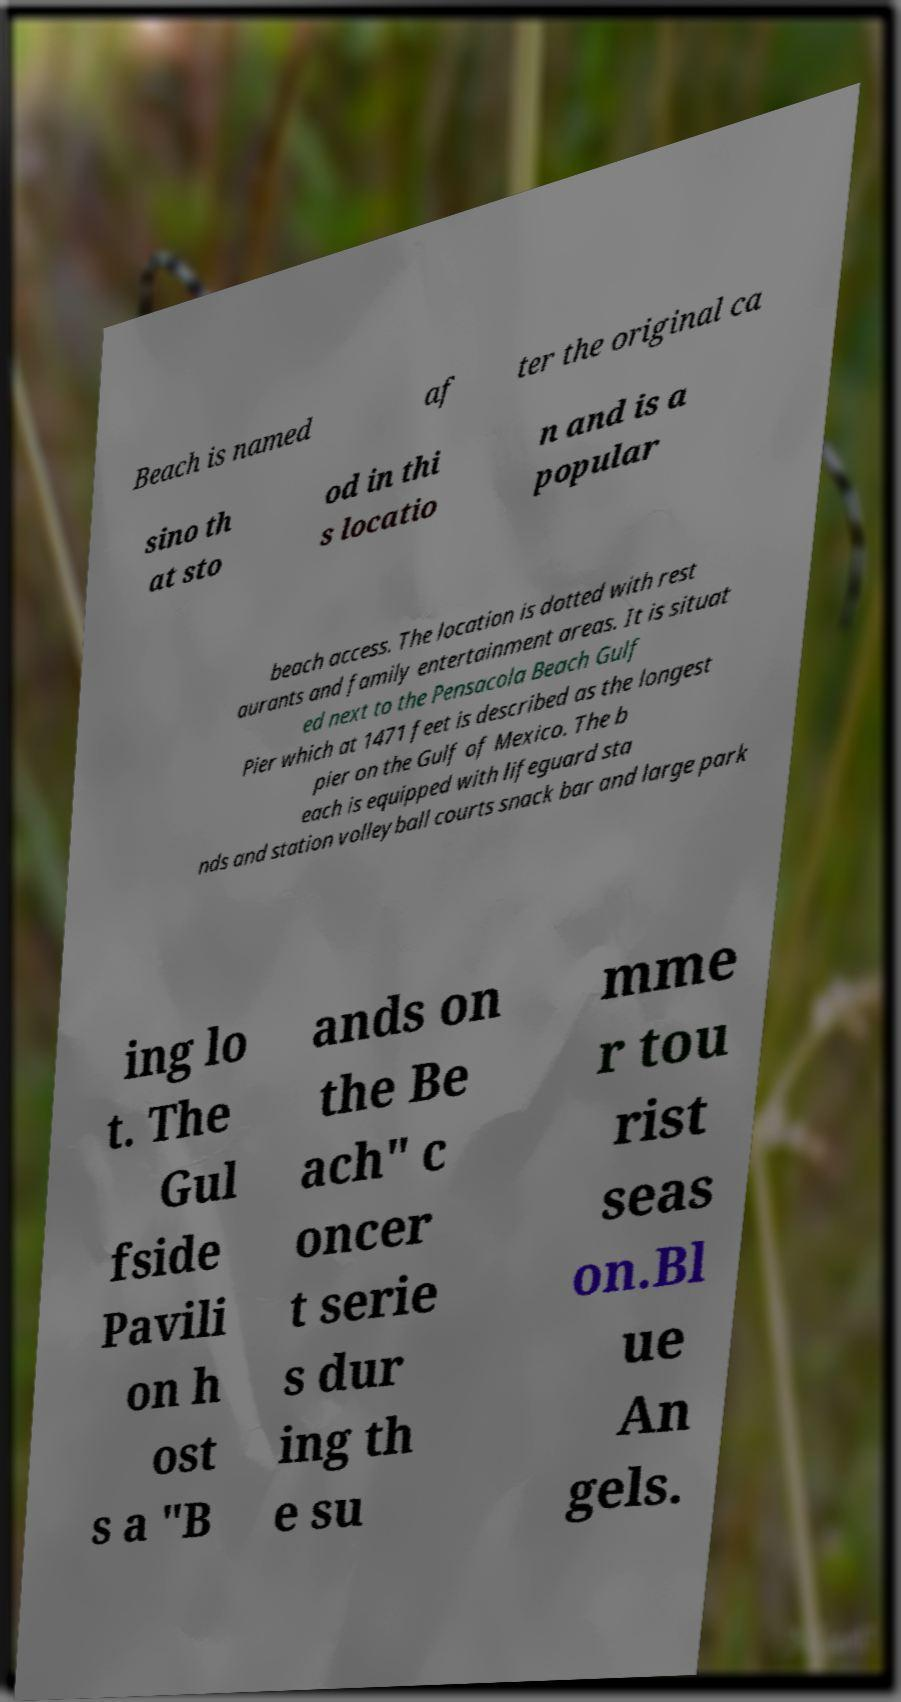There's text embedded in this image that I need extracted. Can you transcribe it verbatim? Beach is named af ter the original ca sino th at sto od in thi s locatio n and is a popular beach access. The location is dotted with rest aurants and family entertainment areas. It is situat ed next to the Pensacola Beach Gulf Pier which at 1471 feet is described as the longest pier on the Gulf of Mexico. The b each is equipped with lifeguard sta nds and station volleyball courts snack bar and large park ing lo t. The Gul fside Pavili on h ost s a "B ands on the Be ach" c oncer t serie s dur ing th e su mme r tou rist seas on.Bl ue An gels. 